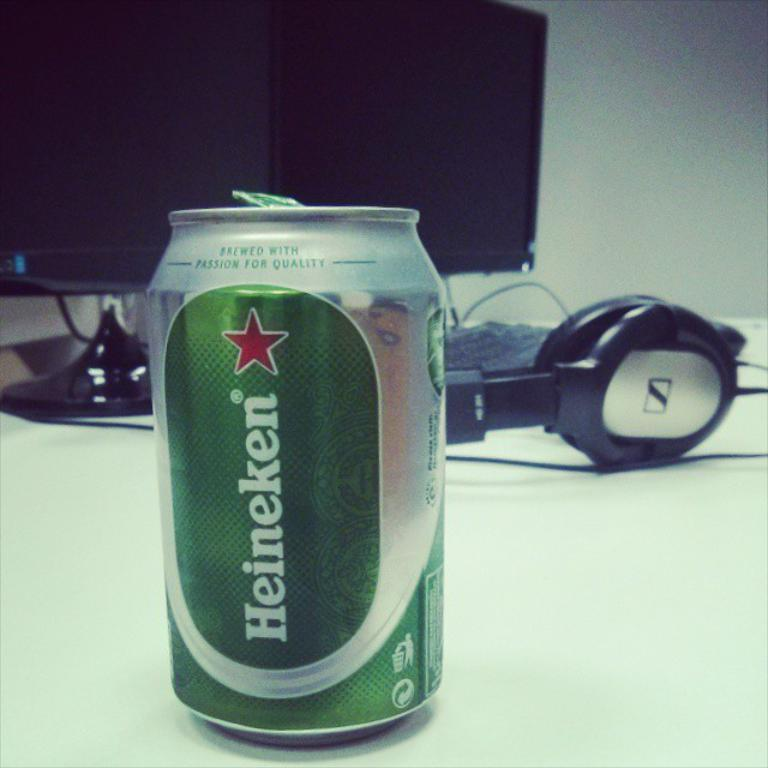<image>
Share a concise interpretation of the image provided. A can of Heineken beer sitting on a desk in front of a computer monitor. 